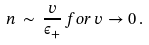Convert formula to latex. <formula><loc_0><loc_0><loc_500><loc_500>n \, \sim \, \frac { v } { \epsilon _ { + } } \, f o r \, v \rightarrow 0 \, .</formula> 